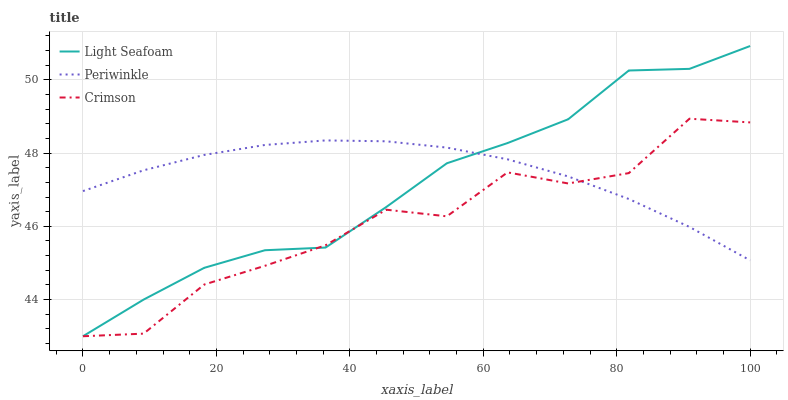Does Crimson have the minimum area under the curve?
Answer yes or no. Yes. Does Periwinkle have the maximum area under the curve?
Answer yes or no. Yes. Does Light Seafoam have the minimum area under the curve?
Answer yes or no. No. Does Light Seafoam have the maximum area under the curve?
Answer yes or no. No. Is Periwinkle the smoothest?
Answer yes or no. Yes. Is Crimson the roughest?
Answer yes or no. Yes. Is Light Seafoam the smoothest?
Answer yes or no. No. Is Light Seafoam the roughest?
Answer yes or no. No. Does Crimson have the lowest value?
Answer yes or no. Yes. Does Periwinkle have the lowest value?
Answer yes or no. No. Does Light Seafoam have the highest value?
Answer yes or no. Yes. Does Periwinkle have the highest value?
Answer yes or no. No. Does Light Seafoam intersect Periwinkle?
Answer yes or no. Yes. Is Light Seafoam less than Periwinkle?
Answer yes or no. No. Is Light Seafoam greater than Periwinkle?
Answer yes or no. No. 